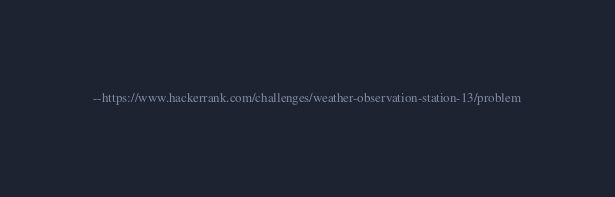<code> <loc_0><loc_0><loc_500><loc_500><_SQL_>--https://www.hackerrank.com/challenges/weather-observation-station-13/problem
</code> 